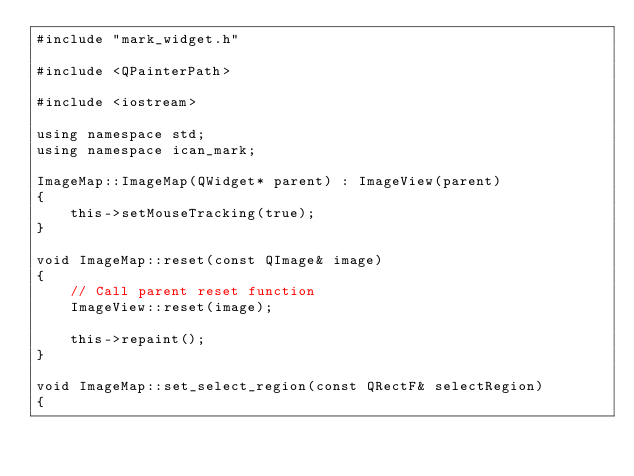Convert code to text. <code><loc_0><loc_0><loc_500><loc_500><_C++_>#include "mark_widget.h"

#include <QPainterPath>

#include <iostream>

using namespace std;
using namespace ican_mark;

ImageMap::ImageMap(QWidget* parent) : ImageView(parent)
{
    this->setMouseTracking(true);
}

void ImageMap::reset(const QImage& image)
{
    // Call parent reset function
    ImageView::reset(image);

    this->repaint();
}

void ImageMap::set_select_region(const QRectF& selectRegion)
{</code> 